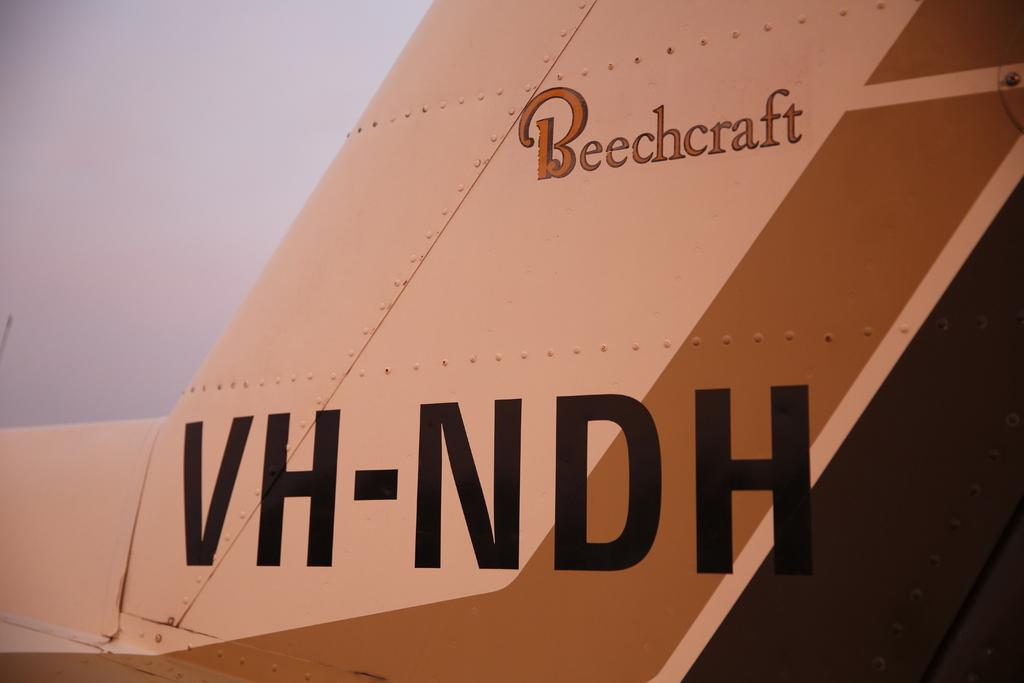<image>
Present a compact description of the photo's key features. The logo for Beechcraft is in red above black lettering. 